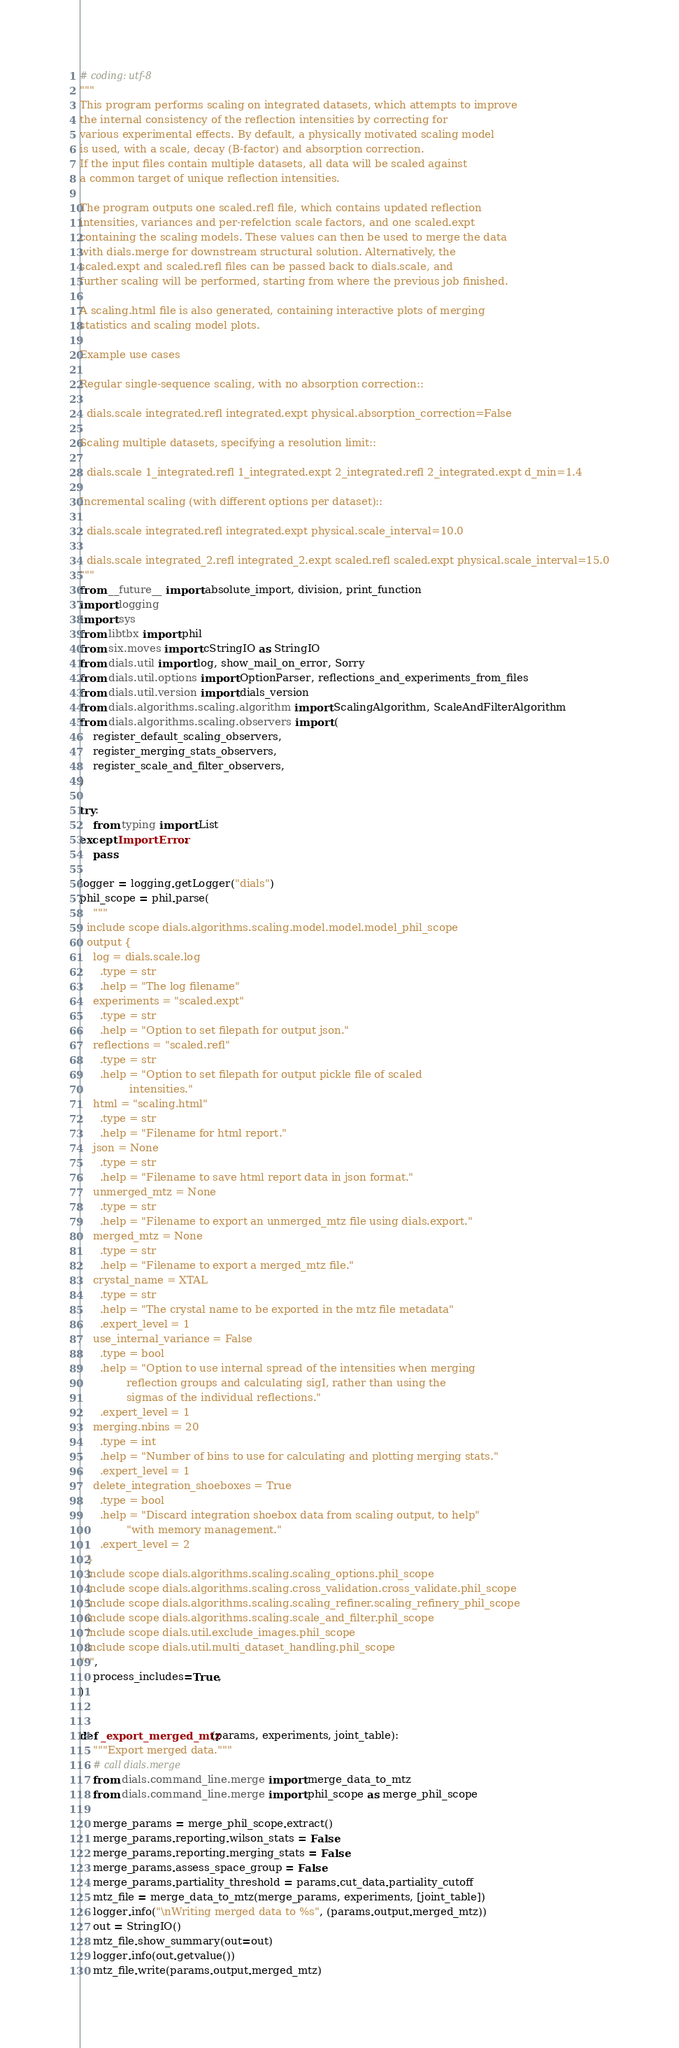<code> <loc_0><loc_0><loc_500><loc_500><_Python_># coding: utf-8
"""
This program performs scaling on integrated datasets, which attempts to improve
the internal consistency of the reflection intensities by correcting for
various experimental effects. By default, a physically motivated scaling model
is used, with a scale, decay (B-factor) and absorption correction.
If the input files contain multiple datasets, all data will be scaled against
a common target of unique reflection intensities.

The program outputs one scaled.refl file, which contains updated reflection
intensities, variances and per-refelction scale factors, and one scaled.expt
containing the scaling models. These values can then be used to merge the data
with dials.merge for downstream structural solution. Alternatively, the
scaled.expt and scaled.refl files can be passed back to dials.scale, and
further scaling will be performed, starting from where the previous job finished.

A scaling.html file is also generated, containing interactive plots of merging
statistics and scaling model plots.

Example use cases

Regular single-sequence scaling, with no absorption correction::

  dials.scale integrated.refl integrated.expt physical.absorption_correction=False

Scaling multiple datasets, specifying a resolution limit::

  dials.scale 1_integrated.refl 1_integrated.expt 2_integrated.refl 2_integrated.expt d_min=1.4

Incremental scaling (with different options per dataset)::

  dials.scale integrated.refl integrated.expt physical.scale_interval=10.0

  dials.scale integrated_2.refl integrated_2.expt scaled.refl scaled.expt physical.scale_interval=15.0
"""
from __future__ import absolute_import, division, print_function
import logging
import sys
from libtbx import phil
from six.moves import cStringIO as StringIO
from dials.util import log, show_mail_on_error, Sorry
from dials.util.options import OptionParser, reflections_and_experiments_from_files
from dials.util.version import dials_version
from dials.algorithms.scaling.algorithm import ScalingAlgorithm, ScaleAndFilterAlgorithm
from dials.algorithms.scaling.observers import (
    register_default_scaling_observers,
    register_merging_stats_observers,
    register_scale_and_filter_observers,
)

try:
    from typing import List
except ImportError:
    pass

logger = logging.getLogger("dials")
phil_scope = phil.parse(
    """
  include scope dials.algorithms.scaling.model.model.model_phil_scope
  output {
    log = dials.scale.log
      .type = str
      .help = "The log filename"
    experiments = "scaled.expt"
      .type = str
      .help = "Option to set filepath for output json."
    reflections = "scaled.refl"
      .type = str
      .help = "Option to set filepath for output pickle file of scaled
               intensities."
    html = "scaling.html"
      .type = str
      .help = "Filename for html report."
    json = None
      .type = str
      .help = "Filename to save html report data in json format."
    unmerged_mtz = None
      .type = str
      .help = "Filename to export an unmerged_mtz file using dials.export."
    merged_mtz = None
      .type = str
      .help = "Filename to export a merged_mtz file."
    crystal_name = XTAL
      .type = str
      .help = "The crystal name to be exported in the mtz file metadata"
      .expert_level = 1
    use_internal_variance = False
      .type = bool
      .help = "Option to use internal spread of the intensities when merging
              reflection groups and calculating sigI, rather than using the
              sigmas of the individual reflections."
      .expert_level = 1
    merging.nbins = 20
      .type = int
      .help = "Number of bins to use for calculating and plotting merging stats."
      .expert_level = 1
    delete_integration_shoeboxes = True
      .type = bool
      .help = "Discard integration shoebox data from scaling output, to help"
              "with memory management."
      .expert_level = 2
  }
  include scope dials.algorithms.scaling.scaling_options.phil_scope
  include scope dials.algorithms.scaling.cross_validation.cross_validate.phil_scope
  include scope dials.algorithms.scaling.scaling_refiner.scaling_refinery_phil_scope
  include scope dials.algorithms.scaling.scale_and_filter.phil_scope
  include scope dials.util.exclude_images.phil_scope
  include scope dials.util.multi_dataset_handling.phil_scope
""",
    process_includes=True,
)


def _export_merged_mtz(params, experiments, joint_table):
    """Export merged data."""
    # call dials.merge
    from dials.command_line.merge import merge_data_to_mtz
    from dials.command_line.merge import phil_scope as merge_phil_scope

    merge_params = merge_phil_scope.extract()
    merge_params.reporting.wilson_stats = False
    merge_params.reporting.merging_stats = False
    merge_params.assess_space_group = False
    merge_params.partiality_threshold = params.cut_data.partiality_cutoff
    mtz_file = merge_data_to_mtz(merge_params, experiments, [joint_table])
    logger.info("\nWriting merged data to %s", (params.output.merged_mtz))
    out = StringIO()
    mtz_file.show_summary(out=out)
    logger.info(out.getvalue())
    mtz_file.write(params.output.merged_mtz)

</code> 